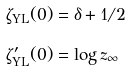<formula> <loc_0><loc_0><loc_500><loc_500>\zeta _ { \text {YL} } ( 0 ) & = \delta + 1 / 2 \\ \zeta _ { \text {YL} } ^ { \prime } ( 0 ) & = \log z _ { \infty }</formula> 